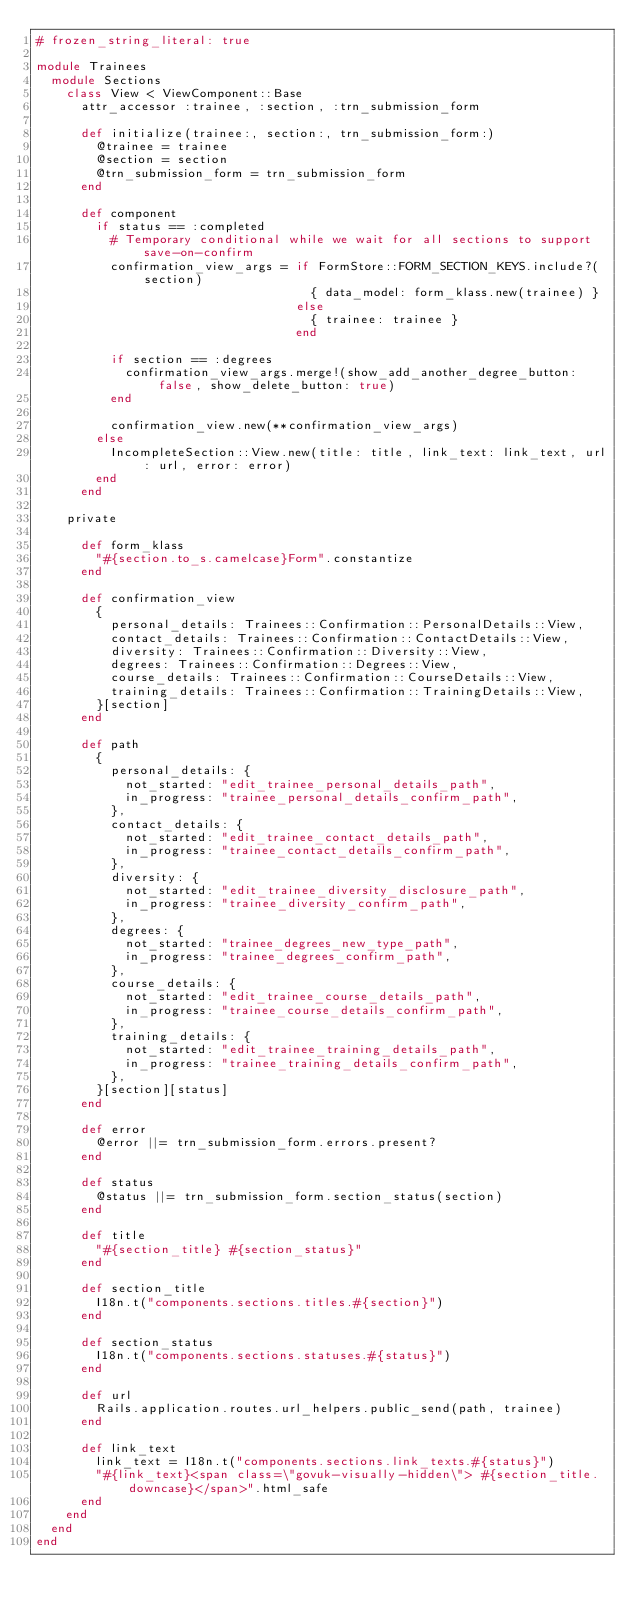<code> <loc_0><loc_0><loc_500><loc_500><_Ruby_># frozen_string_literal: true

module Trainees
  module Sections
    class View < ViewComponent::Base
      attr_accessor :trainee, :section, :trn_submission_form

      def initialize(trainee:, section:, trn_submission_form:)
        @trainee = trainee
        @section = section
        @trn_submission_form = trn_submission_form
      end

      def component
        if status == :completed
          # Temporary conditional while we wait for all sections to support save-on-confirm
          confirmation_view_args = if FormStore::FORM_SECTION_KEYS.include?(section)
                                     { data_model: form_klass.new(trainee) }
                                   else
                                     { trainee: trainee }
                                   end

          if section == :degrees
            confirmation_view_args.merge!(show_add_another_degree_button: false, show_delete_button: true)
          end

          confirmation_view.new(**confirmation_view_args)
        else
          IncompleteSection::View.new(title: title, link_text: link_text, url: url, error: error)
        end
      end

    private

      def form_klass
        "#{section.to_s.camelcase}Form".constantize
      end

      def confirmation_view
        {
          personal_details: Trainees::Confirmation::PersonalDetails::View,
          contact_details: Trainees::Confirmation::ContactDetails::View,
          diversity: Trainees::Confirmation::Diversity::View,
          degrees: Trainees::Confirmation::Degrees::View,
          course_details: Trainees::Confirmation::CourseDetails::View,
          training_details: Trainees::Confirmation::TrainingDetails::View,
        }[section]
      end

      def path
        {
          personal_details: {
            not_started: "edit_trainee_personal_details_path",
            in_progress: "trainee_personal_details_confirm_path",
          },
          contact_details: {
            not_started: "edit_trainee_contact_details_path",
            in_progress: "trainee_contact_details_confirm_path",
          },
          diversity: {
            not_started: "edit_trainee_diversity_disclosure_path",
            in_progress: "trainee_diversity_confirm_path",
          },
          degrees: {
            not_started: "trainee_degrees_new_type_path",
            in_progress: "trainee_degrees_confirm_path",
          },
          course_details: {
            not_started: "edit_trainee_course_details_path",
            in_progress: "trainee_course_details_confirm_path",
          },
          training_details: {
            not_started: "edit_trainee_training_details_path",
            in_progress: "trainee_training_details_confirm_path",
          },
        }[section][status]
      end

      def error
        @error ||= trn_submission_form.errors.present?
      end

      def status
        @status ||= trn_submission_form.section_status(section)
      end

      def title
        "#{section_title} #{section_status}"
      end

      def section_title
        I18n.t("components.sections.titles.#{section}")
      end

      def section_status
        I18n.t("components.sections.statuses.#{status}")
      end

      def url
        Rails.application.routes.url_helpers.public_send(path, trainee)
      end

      def link_text
        link_text = I18n.t("components.sections.link_texts.#{status}")
        "#{link_text}<span class=\"govuk-visually-hidden\"> #{section_title.downcase}</span>".html_safe
      end
    end
  end
end
</code> 